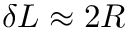Convert formula to latex. <formula><loc_0><loc_0><loc_500><loc_500>\delta L \approx 2 R</formula> 